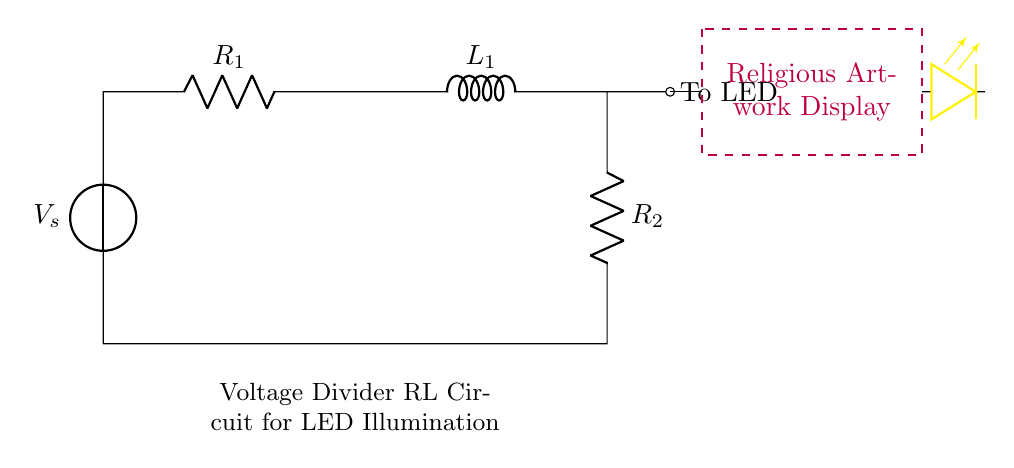What is the value of the resistor R1? The circuit diagram does not specify any numerical value for R1; hence, we refer to it as simply R1 without a specific magnitude.
Answer: R1 What is the purpose of the inductor L1 in this circuit? The inductor L1 is used to store energy magnetically and helps to smooth out current changes in the circuit, which is particularly beneficial in maintaining a stable LED illumination.
Answer: Energy storage What is the total resistance seen by the voltage source? The total resistance in this series circuit can be calculated as the sum of R1, R2, and the impedance of the inductor L1 at steady state; however, L1 behaves like a short circuit at DC, making the total resistance simply R1 plus R2.
Answer: R1 + R2 How does the voltage drop across R2 affect the LED? The voltage drop across R2 determines the voltage supplied to the LED; if the drop is sufficient and within the LED's operating range, it will illuminate.
Answer: Supplies LED voltage What kind of circuit is depicted in the diagram? The circuit is a voltage divider RL circuit, which consists of resistors and an inductor and is designed to divide voltage for proper LED illumination.
Answer: Voltage divider RL What happens to the current when the LED is connected to the circuit? When the LED is connected, it draws current through the circuit which is governed by the voltage drop across R2, affecting the overall current based on Ohm's Law and the characteristics of the inductor.
Answer: Current is drawn What is the primary function of the voltage source in this circuit? The voltage source V_s provides the necessary electrical energy to power the circuit, ensuring that the components, including the LED, receive the voltage required for operation.
Answer: Provide electrical energy 